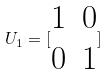<formula> <loc_0><loc_0><loc_500><loc_500>U _ { 1 } = [ \begin{matrix} 1 & 0 \\ 0 & 1 \end{matrix} ]</formula> 